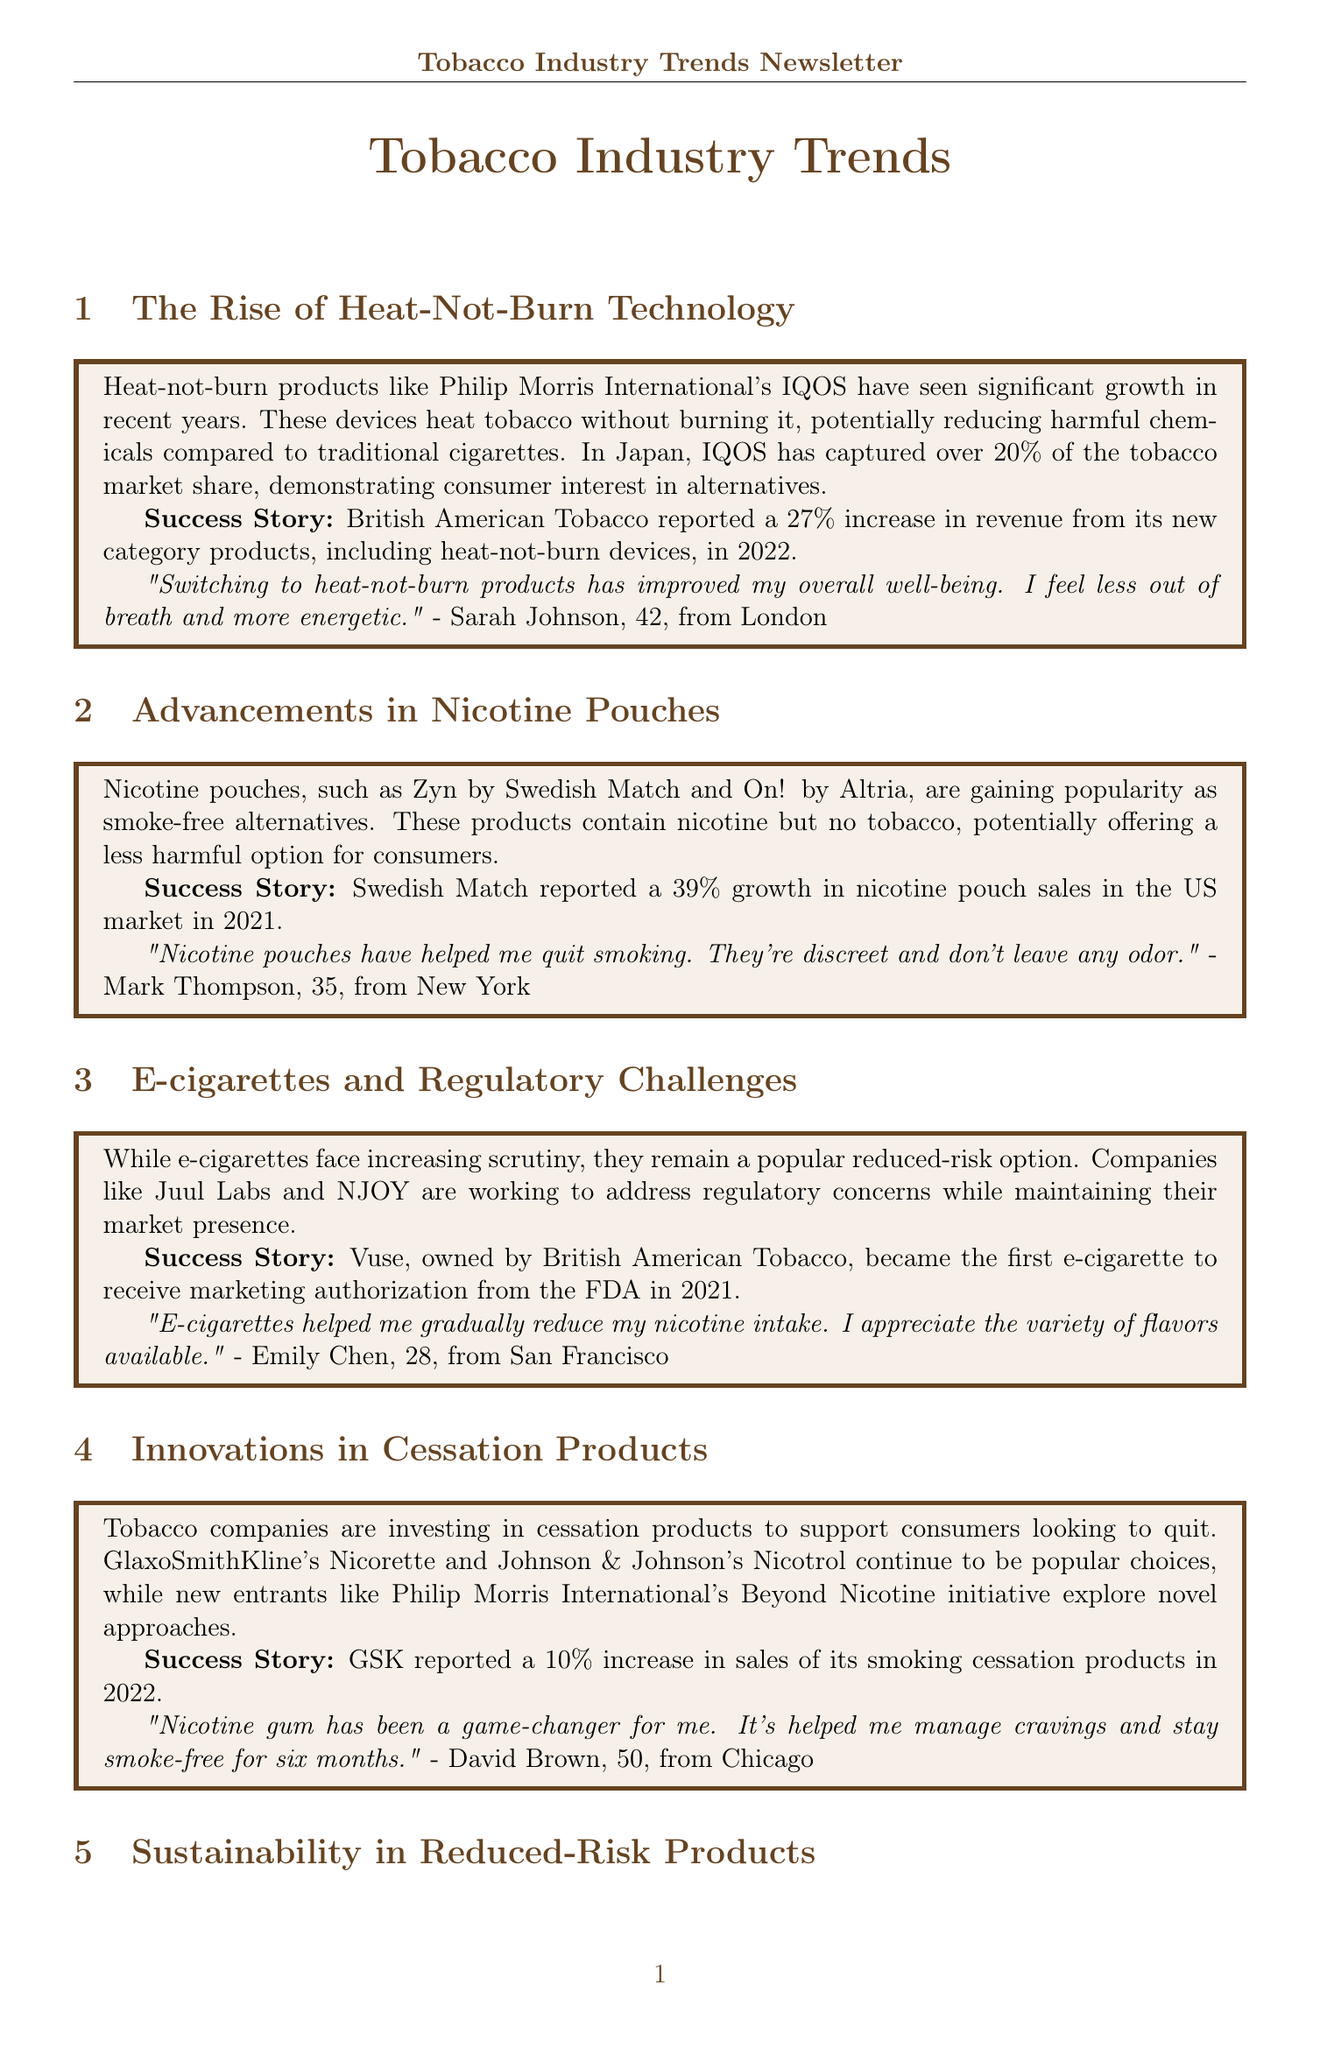What product captured over 20% of the tobacco market share in Japan? The document states that IQOS has captured over 20% of the tobacco market share in Japan.
Answer: IQOS What was the percentage increase in revenue reported by British American Tobacco in 2022? According to the document, British American Tobacco reported a 27% increase in revenue from its new category products in 2022.
Answer: 27% What type of product is Zyn? The document classifies Zyn as a nicotine pouch, which is a smoke-free alternative.
Answer: Nicotine pouch What was the growth percentage of nicotine pouch sales reported by Swedish Match in 2021? The document mentions that Swedish Match reported a 39% growth in nicotine pouch sales in the US market in 2021.
Answer: 39% Which e-cigarette received marketing authorization from the FDA in 2021? The document states that Vuse became the first e-cigarette to receive marketing authorization from the FDA in 2021.
Answer: Vuse What is the focus of tobacco companies in their reduced-risk product lines? The document indicates that tobacco companies are focusing on sustainability in their reduced-risk product lines.
Answer: Sustainability How many months has David Brown stayed smoke-free using nicotine gum? According to the document, David Brown has stayed smoke-free for six months using nicotine gum.
Answer: Six months What commendable environmental target did Japan Tobacco International achieve in 2022? The document highlights that Japan Tobacco International achieved a 100% renewable electricity target for its reduced-risk product manufacturing facilities in 2022.
Answer: 100% renewable electricity target What type of testimonials are featured in this newsletter? This newsletter features consumer testimonials that reflect individual experiences with reduced-risk tobacco products.
Answer: Consumer testimonials 